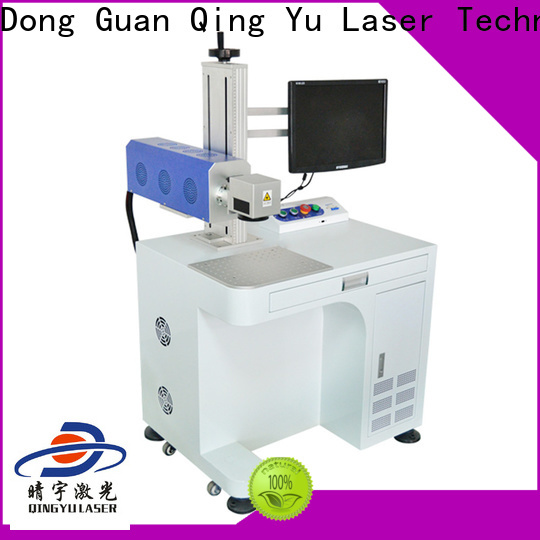How does the safety feature impact the operation of this machine? The safety features of this laser engraving machine, such as the prominently placed emergency stop button, significantly impact its operation by ensuring user protection. In the event of a malfunction or hazardous situation, the operator can quickly halt the machine, preventing potential accidents. This safety measure not only protects workers from harm but also minimizes the risk of damage to the machine and materials being processed. Implementing such safety features is particularly crucial in industrial settings where high-powered lasers are involved, ensuring both compliance with safety regulations and maintaining a safe working environment. Can you describe any other safety measures this machine might have? In addition to the emergency stop button, the machine likely includes several other safety measures. It may have protective enclosures around the laser to prevent accidental exposure to the laser beam. Sensors could be in place to detect the presence of materials and ensure the machine is operating correctly before engraving begins. Additionally, interlock systems might be integrated to automatically shut down the laser if a safety breach is detected, such as opening a protective cover during operation. These features collectively enhance operational safety, making the machine suitable for industrial environments where rigorous safety standards are essential. 